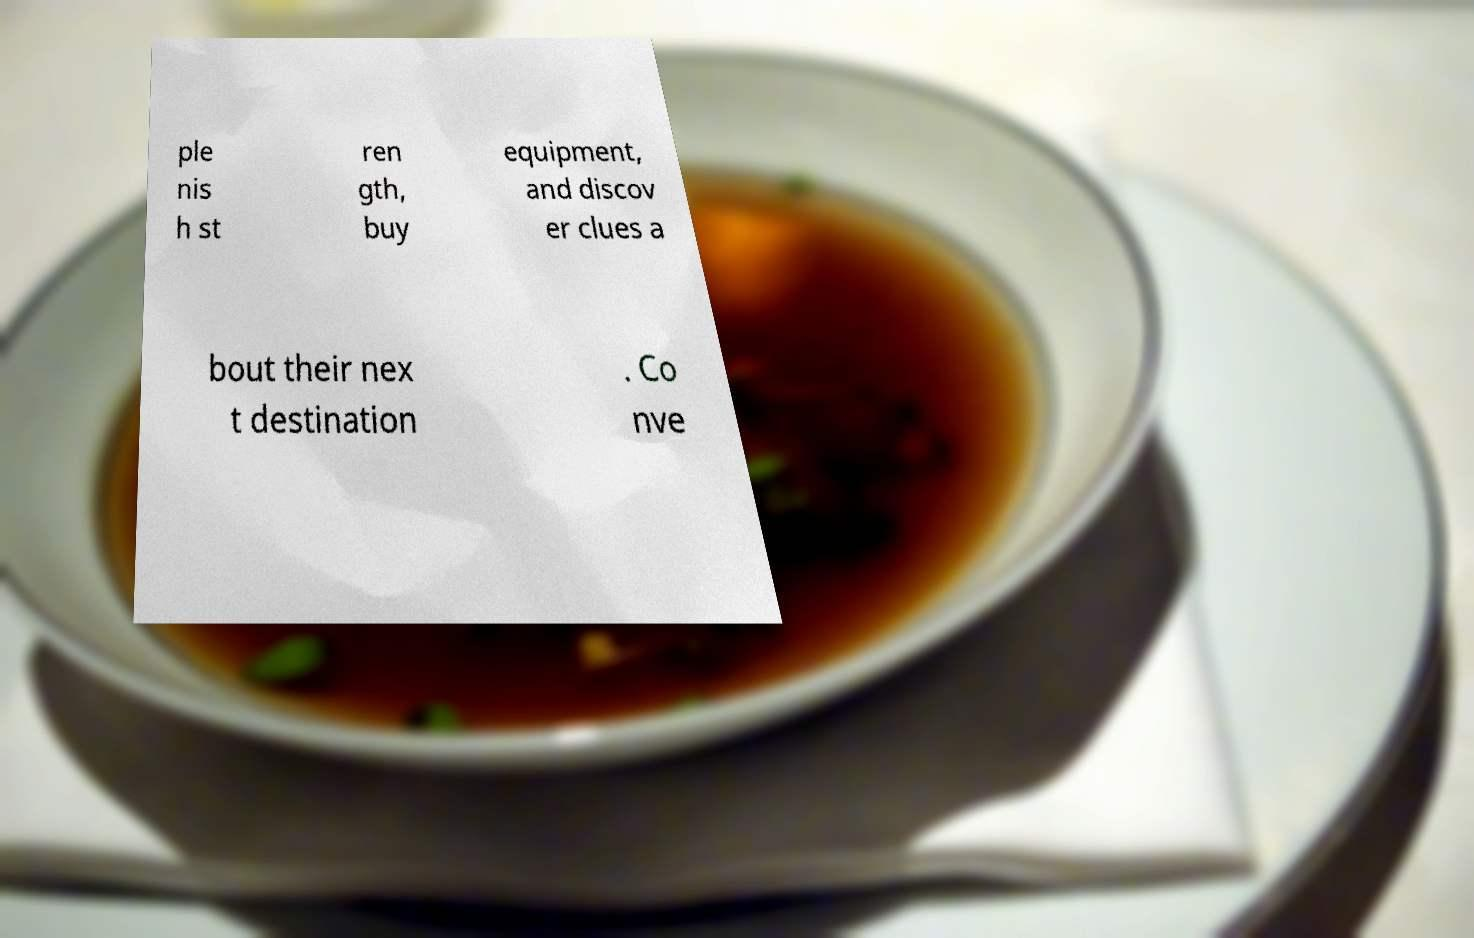Can you accurately transcribe the text from the provided image for me? ple nis h st ren gth, buy equipment, and discov er clues a bout their nex t destination . Co nve 